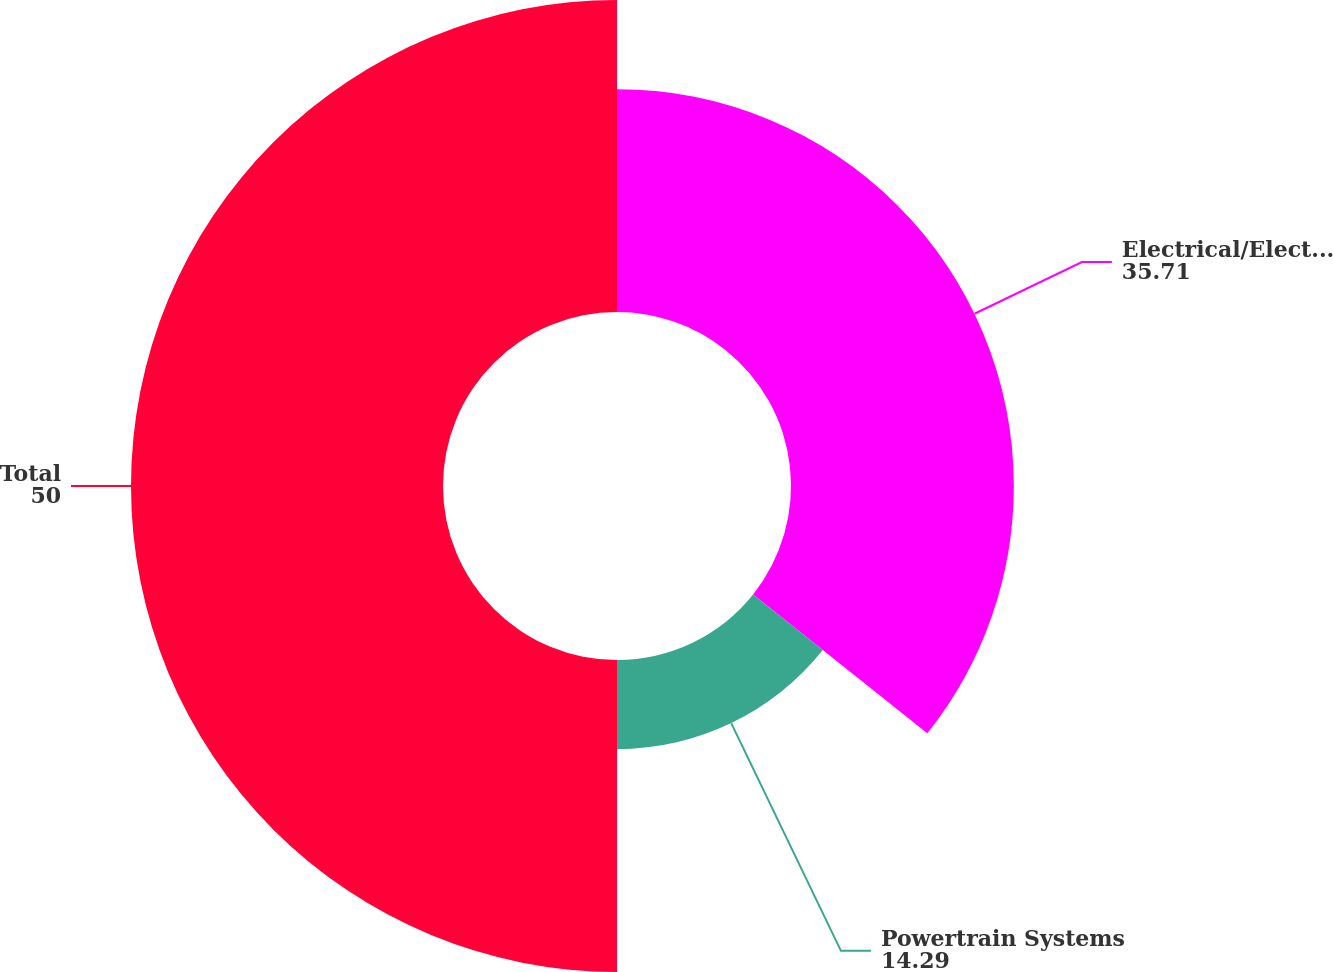Convert chart. <chart><loc_0><loc_0><loc_500><loc_500><pie_chart><fcel>Electrical/Electronic<fcel>Powertrain Systems<fcel>Total<nl><fcel>35.71%<fcel>14.29%<fcel>50.0%<nl></chart> 